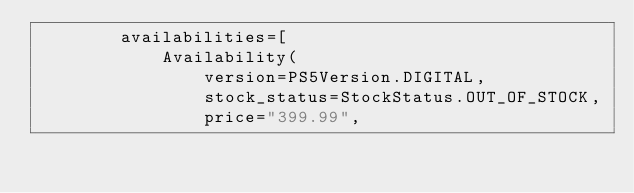<code> <loc_0><loc_0><loc_500><loc_500><_Python_>        availabilities=[
            Availability(
                version=PS5Version.DIGITAL,
                stock_status=StockStatus.OUT_OF_STOCK,
                price="399.99",</code> 